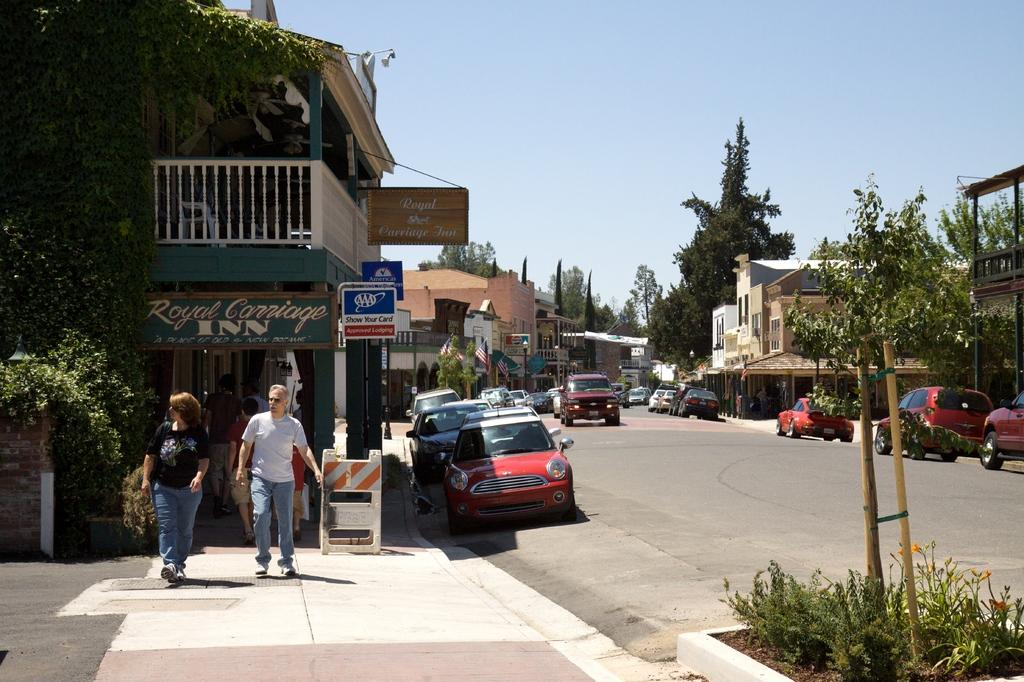What can be seen on the road in the image? There are vehicles on the road in the image. Who or what else is present in the image? There are people, plants, buildings, trees, flags, name boards, and sticks in the image. What is visible in the background of the image? The sky is visible in the background of the image. Can you describe the objects in the image? There are other objects in the image, but their specific details are not mentioned in the provided facts. Can you recite the verse written on the button in the image? There is no button or verse present in the image. How do the people in the image jump over the trees? There is no jumping or interaction with trees depicted in the image. 